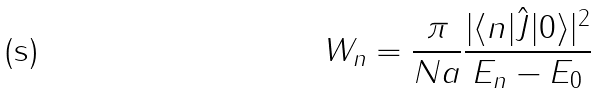Convert formula to latex. <formula><loc_0><loc_0><loc_500><loc_500>W _ { n } = \frac { \pi } { N a } \frac { | \langle n | \hat { J } | 0 \rangle | ^ { 2 } } { E _ { n } - E _ { 0 } }</formula> 